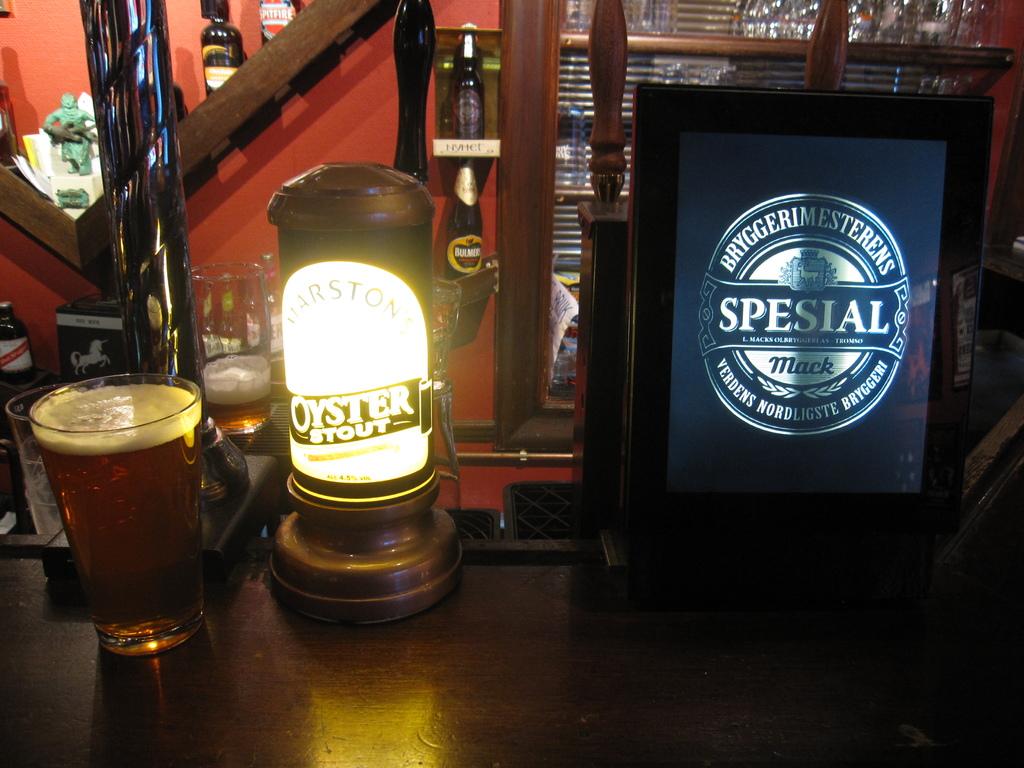What brand of stout is lit up?
Give a very brief answer. Oyster. What is the brand name on the screen?
Your answer should be compact. Spesial. 